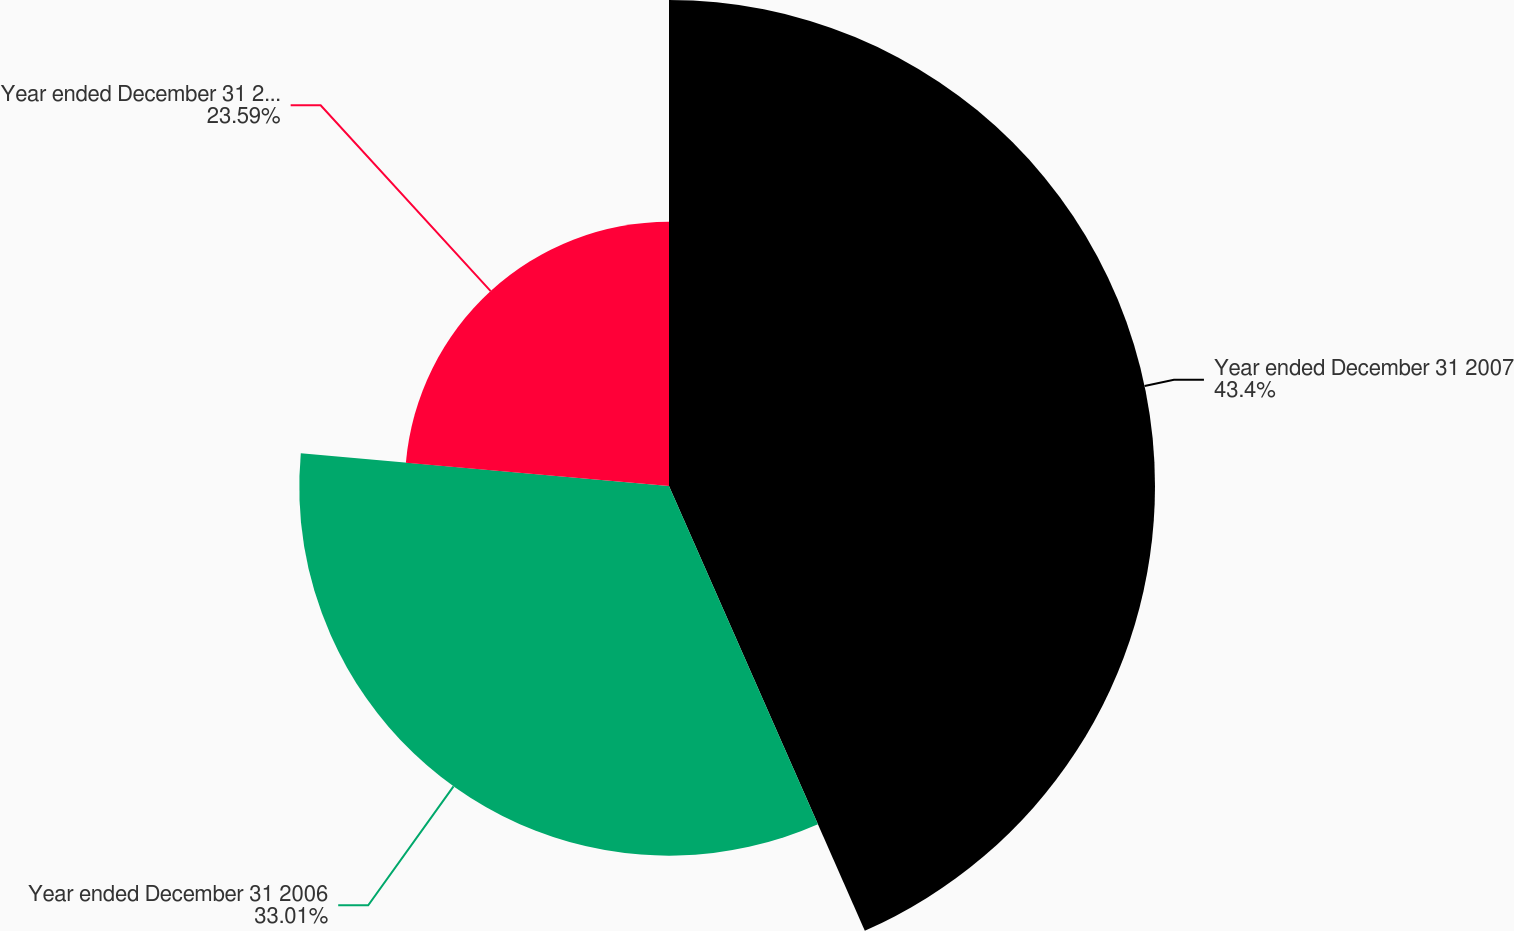Convert chart. <chart><loc_0><loc_0><loc_500><loc_500><pie_chart><fcel>Year ended December 31 2007<fcel>Year ended December 31 2006<fcel>Year ended December 31 2005<nl><fcel>43.4%<fcel>33.01%<fcel>23.59%<nl></chart> 